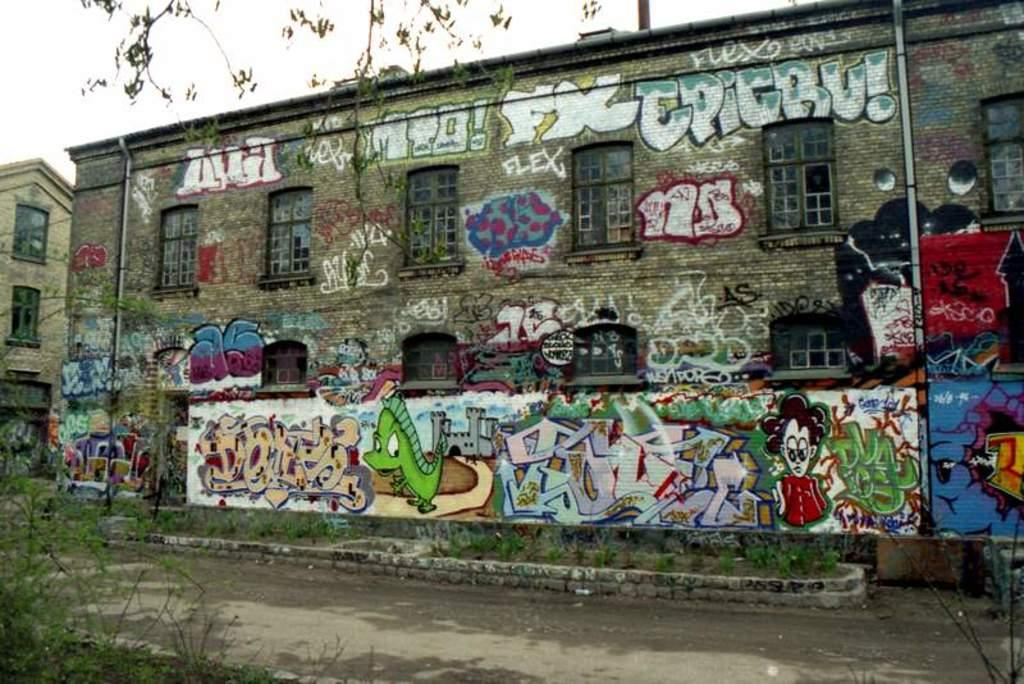What type of living organisms can be seen in the image? Plants can be seen in the image. How many buildings are present in the image? There are two buildings in the image. What is on one of the buildings? There is graffiti on one of the buildings. What is visible in the background of the image? The sky is visible in the background of the image. Who is the servant cooking in the image? There is no servant or cooking activity depicted in the image. 